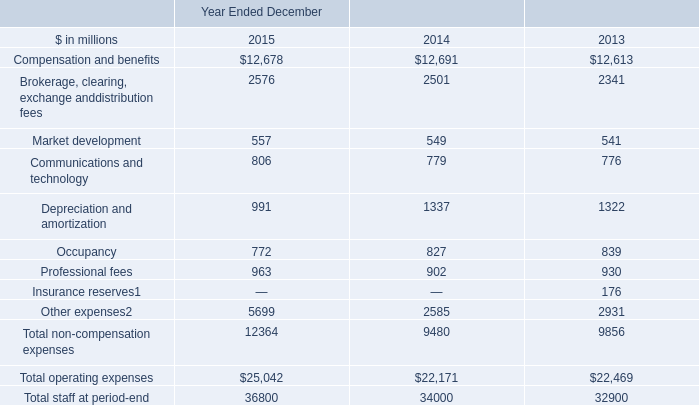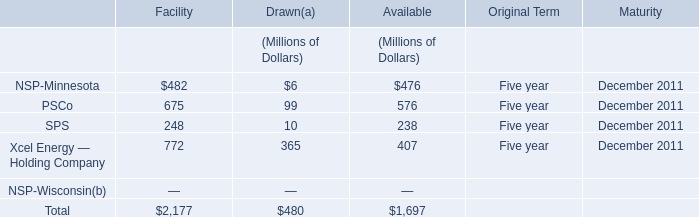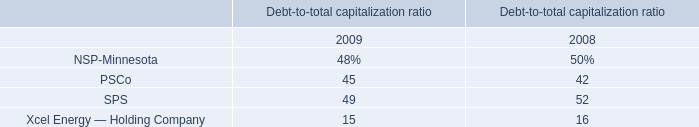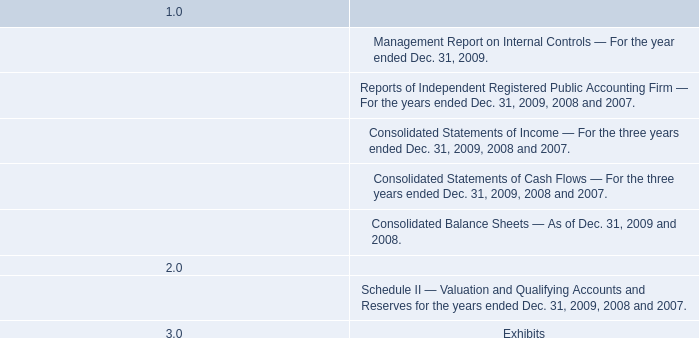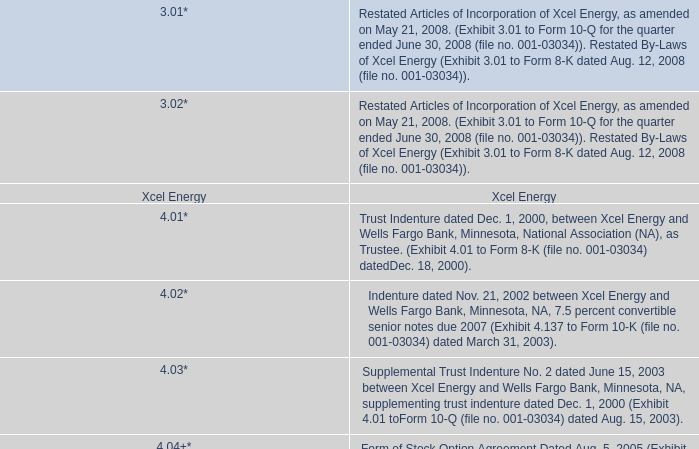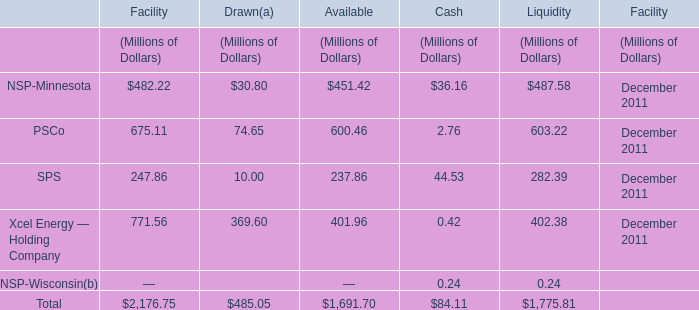What's the total value of all elements that are smaller than 100 in Drawn? (in Million) 
Computations: ((30.8 + 74.65) + 10)
Answer: 115.45. 